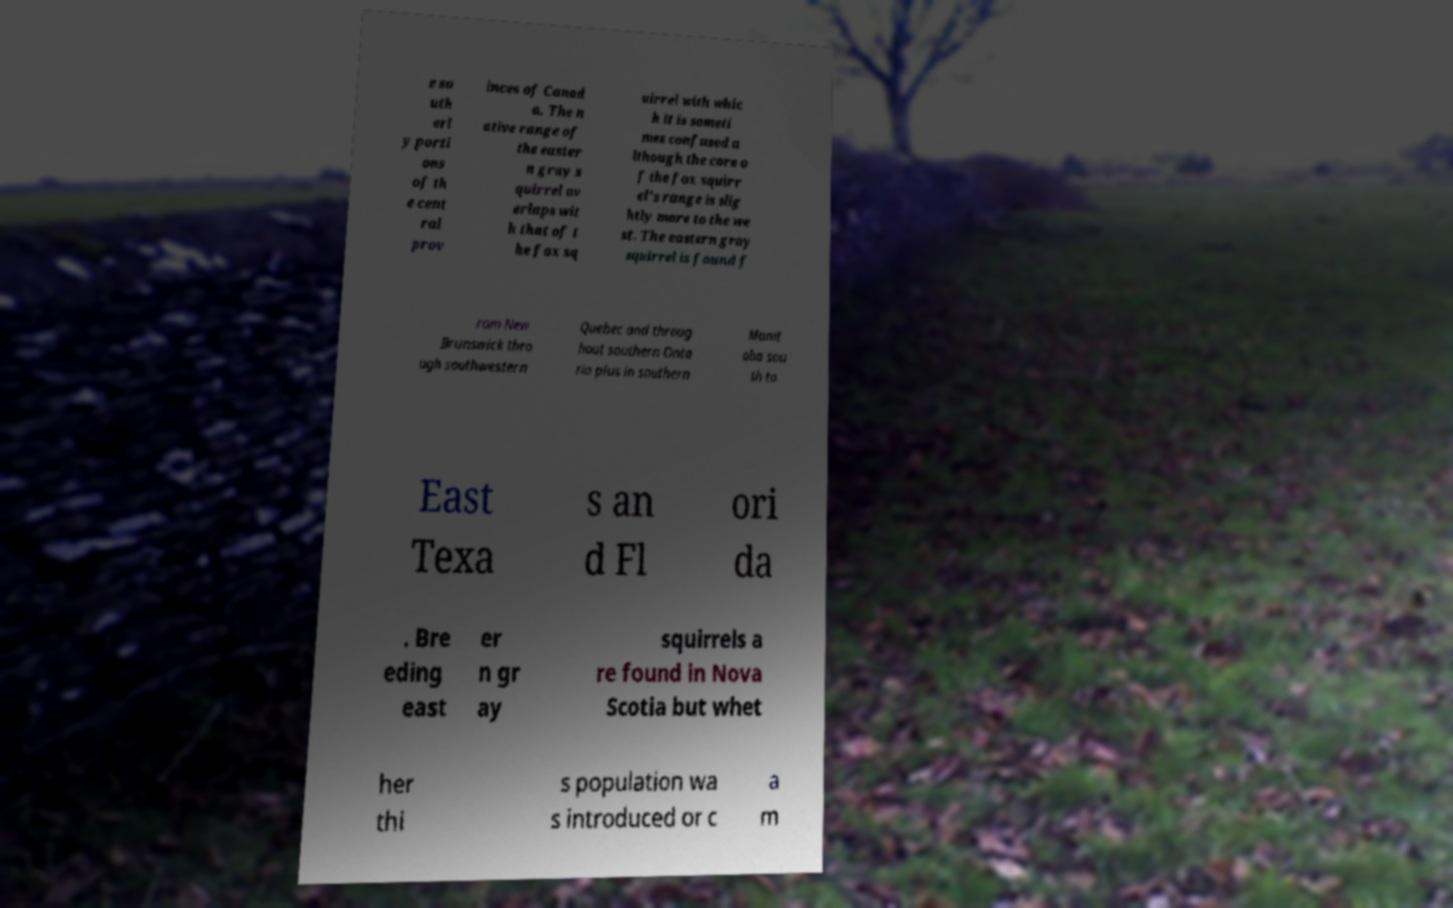Could you extract and type out the text from this image? e so uth erl y porti ons of th e cent ral prov inces of Canad a. The n ative range of the easter n gray s quirrel ov erlaps wit h that of t he fox sq uirrel with whic h it is someti mes confused a lthough the core o f the fox squirr el's range is slig htly more to the we st. The eastern gray squirrel is found f rom New Brunswick thro ugh southwestern Quebec and throug hout southern Onta rio plus in southern Manit oba sou th to East Texa s an d Fl ori da . Bre eding east er n gr ay squirrels a re found in Nova Scotia but whet her thi s population wa s introduced or c a m 